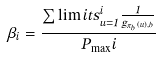<formula> <loc_0><loc_0><loc_500><loc_500>\beta _ { i } = \frac { \sum \lim i t s _ { u = 1 } ^ { i } { \frac { 1 } { g _ { \pi _ { b } ( u ) , b } } } } { P _ { \max } i }</formula> 